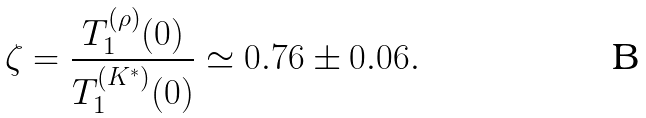<formula> <loc_0><loc_0><loc_500><loc_500>\zeta = \frac { T _ { 1 } ^ { ( \rho ) } ( 0 ) } { T _ { 1 } ^ { ( K ^ { * } ) } ( 0 ) } \simeq 0 . 7 6 \pm 0 . 0 6 .</formula> 